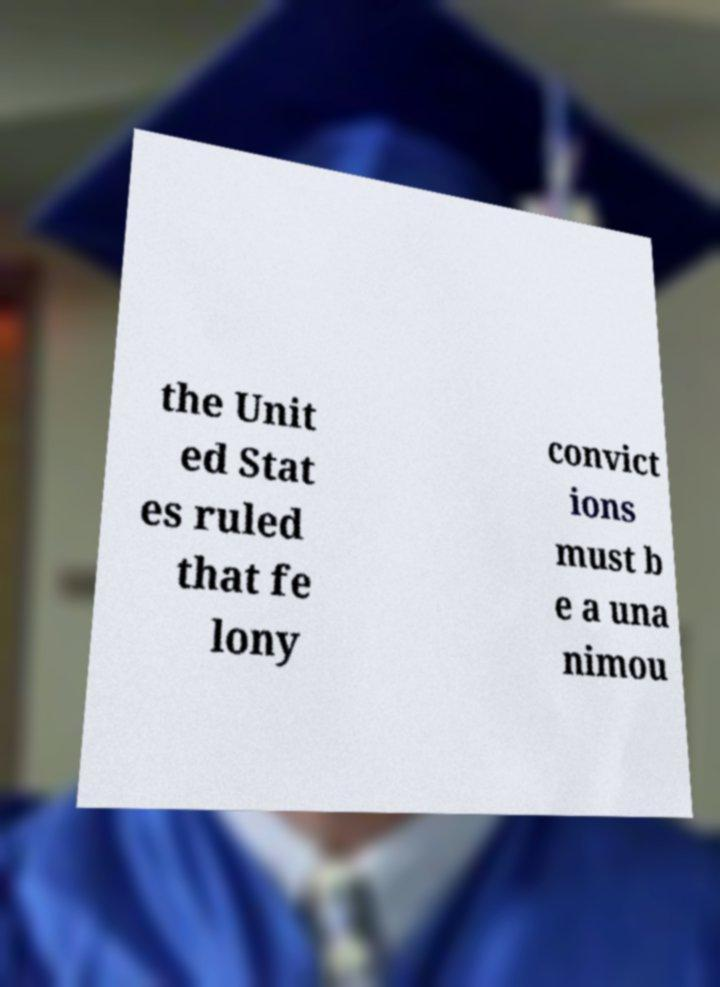Please identify and transcribe the text found in this image. the Unit ed Stat es ruled that fe lony convict ions must b e a una nimou 